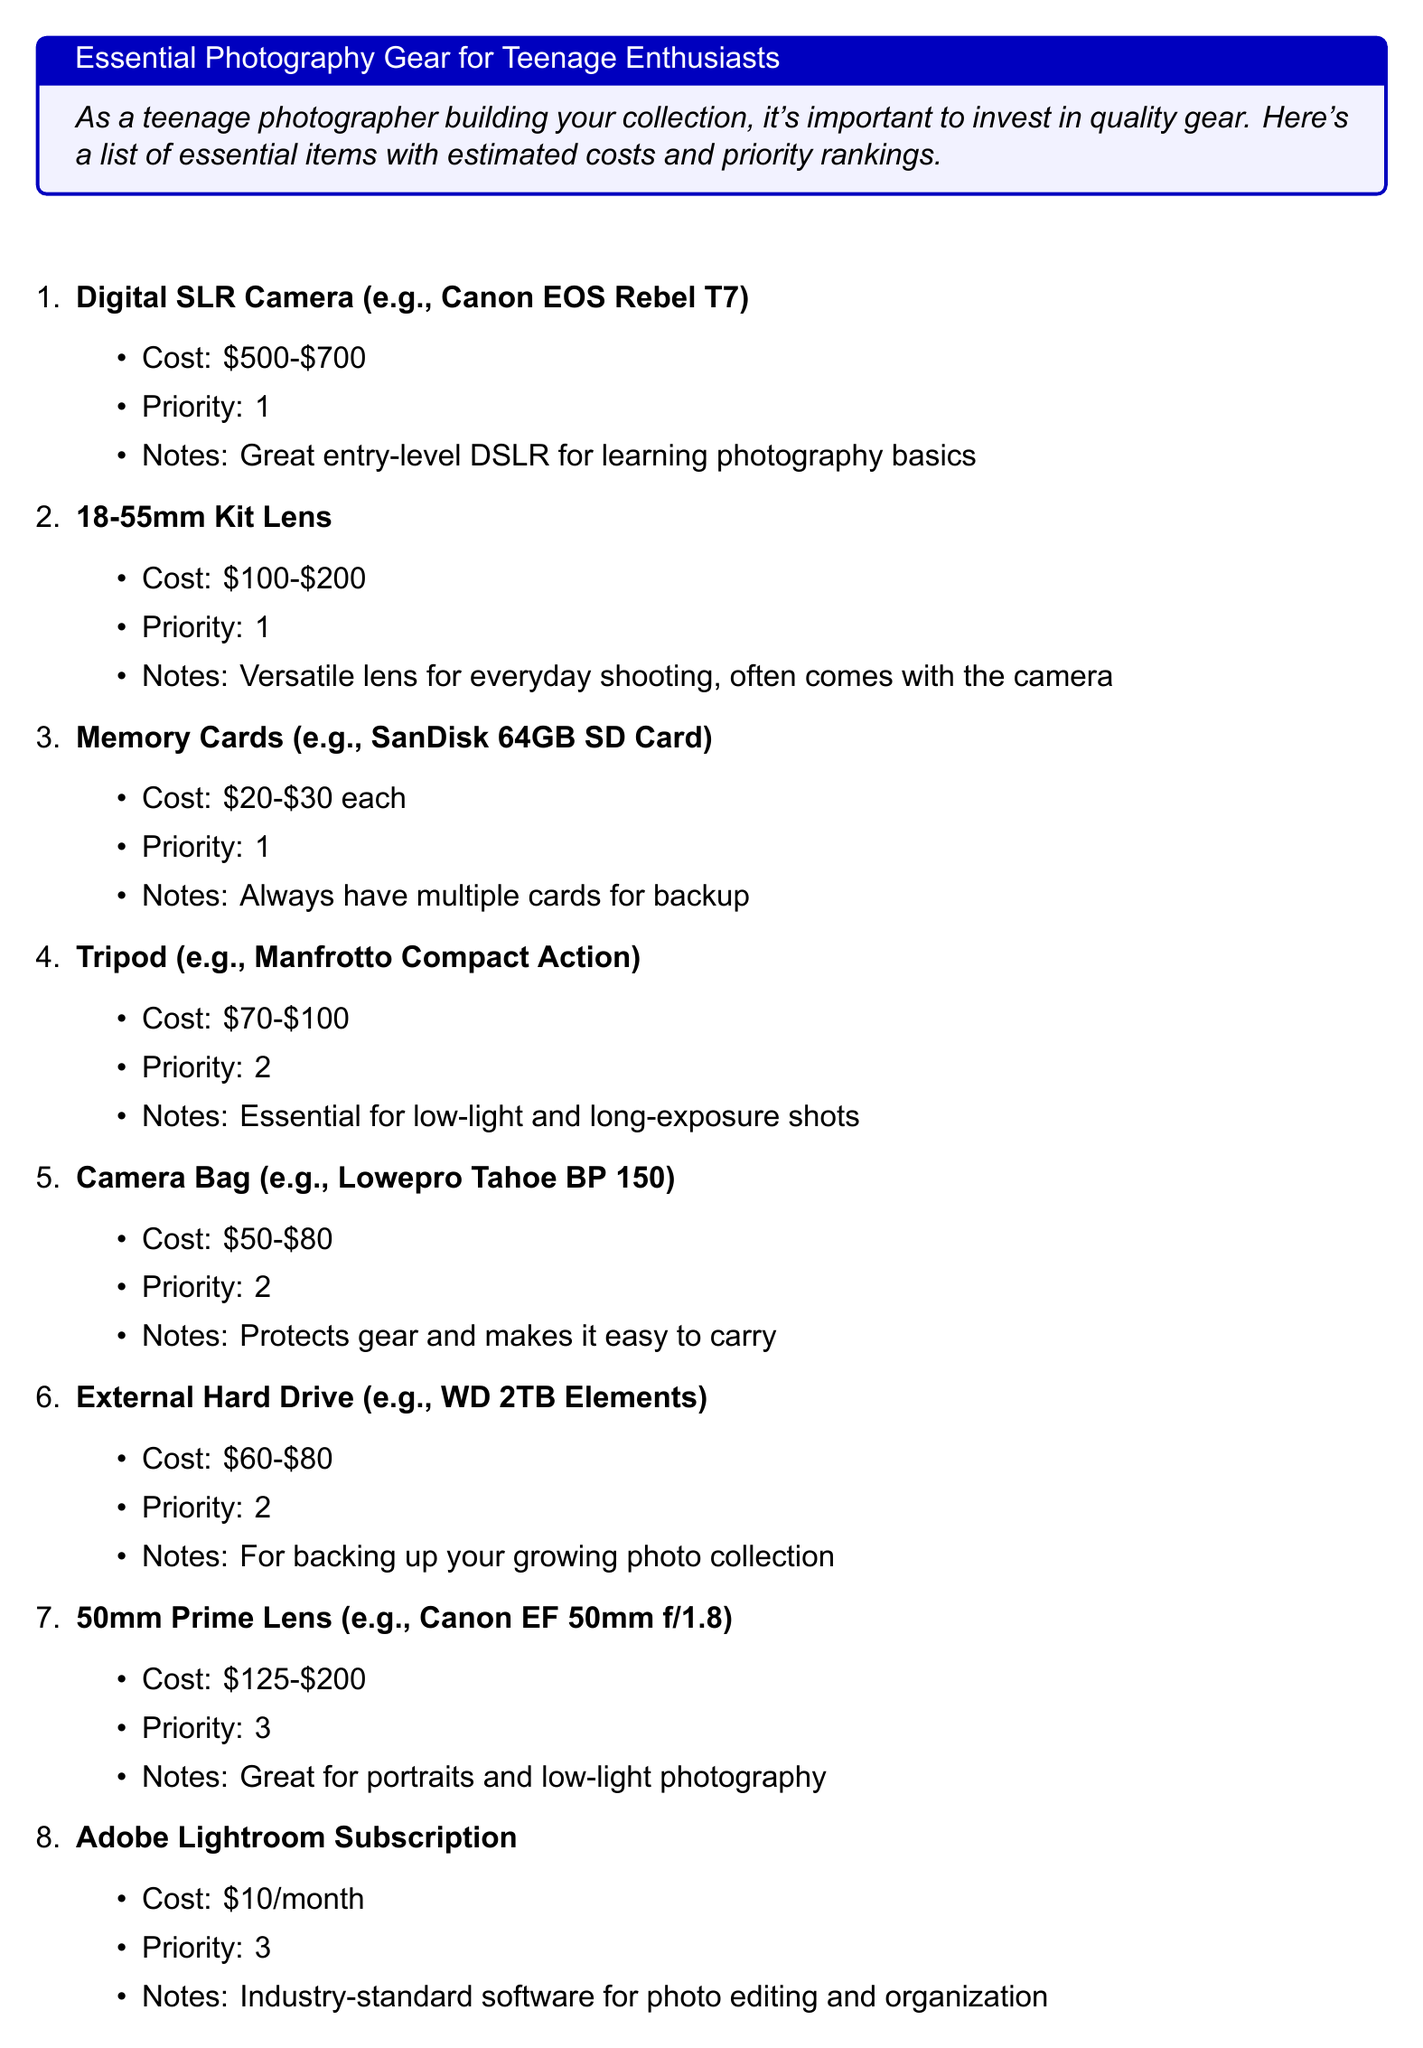What is the title of the document? The title is stated at the beginning of the document, indicating the main topic.
Answer: Essential Photography Gear for Teenage Enthusiasts What is the estimated cost of a Digital SLR Camera? The document lists the cost range for the Digital SLR Camera under its details.
Answer: $500-$700 What priority ranking is assigned to the Memory Cards? The priority ranking is explicitly mentioned in the details of the item.
Answer: 1 How much does an Adobe Lightroom Subscription cost per month? The document provides the monthly cost of the subscription in the details section.
Answer: $10/month What type of lens is suggested for portraits and low-light photography? The document specifies the 50mm Prime Lens for this purpose.
Answer: 50mm Prime Lens Which item is essential for low-light and long-exposure shots? The document indicates a specific item designated for this task.
Answer: Tripod What should be done with the highest priority items? The conclusion suggests a specific action regarding these items.
Answer: Start with them How many items are listed in the gear list? The total number of items can be counted from the list presented in the document.
Answer: 8 